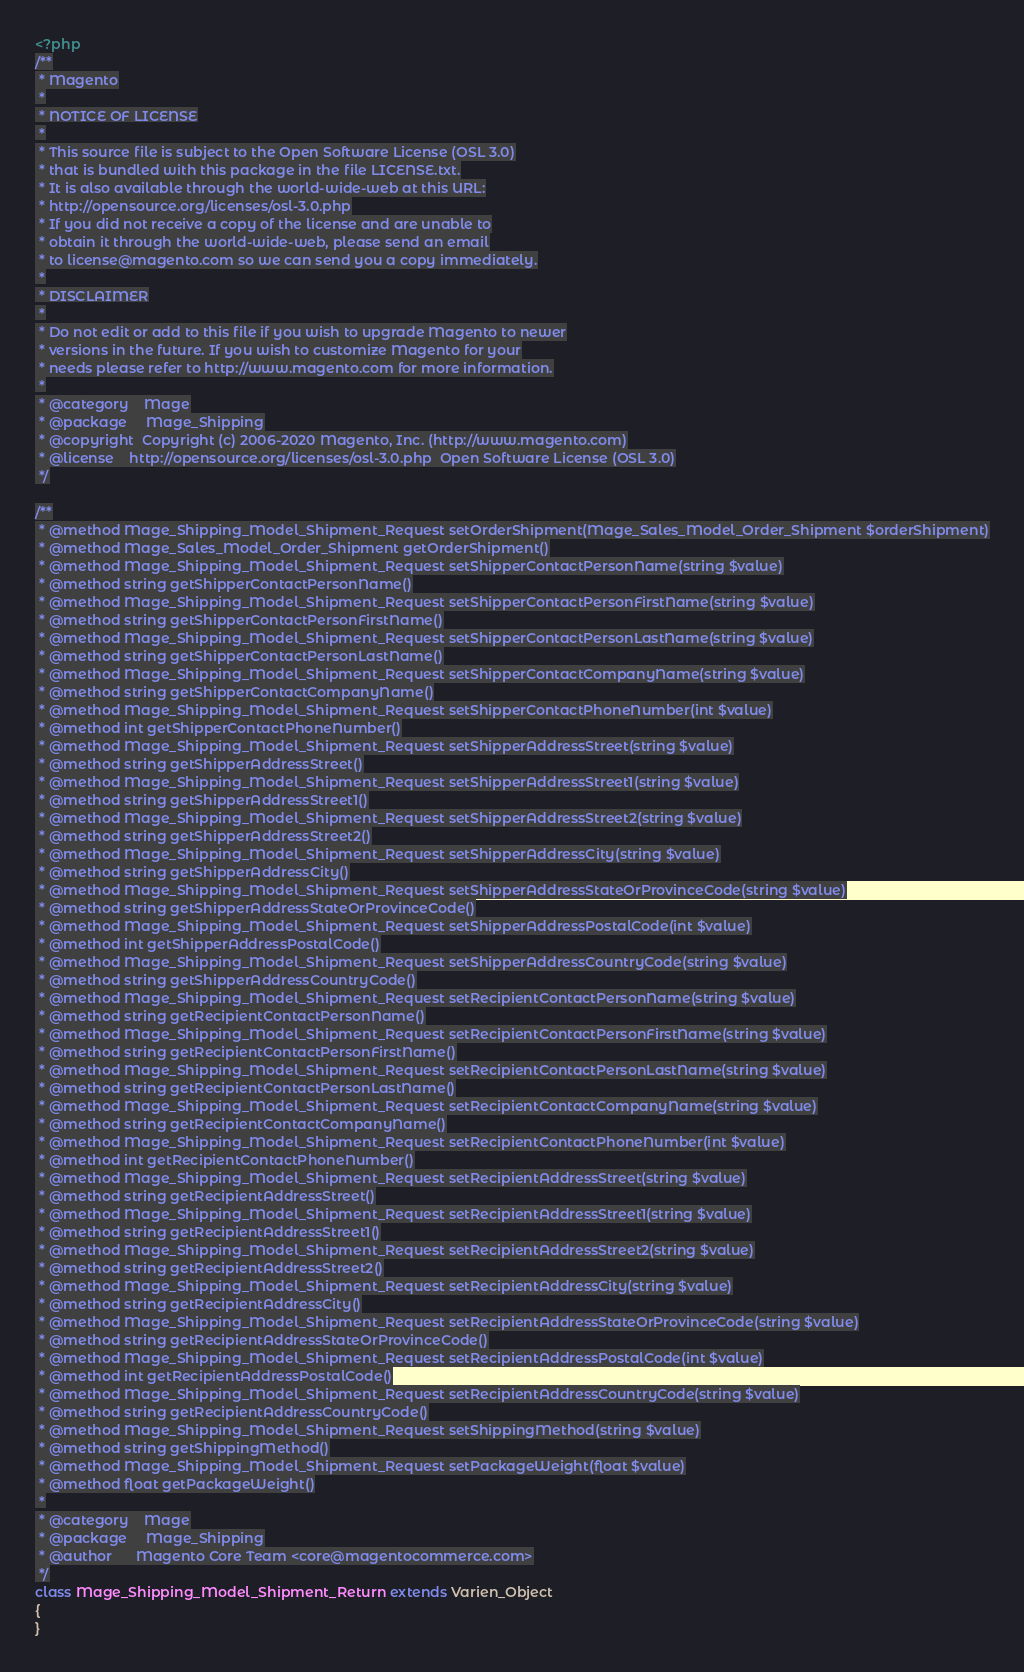Convert code to text. <code><loc_0><loc_0><loc_500><loc_500><_PHP_><?php
/**
 * Magento
 *
 * NOTICE OF LICENSE
 *
 * This source file is subject to the Open Software License (OSL 3.0)
 * that is bundled with this package in the file LICENSE.txt.
 * It is also available through the world-wide-web at this URL:
 * http://opensource.org/licenses/osl-3.0.php
 * If you did not receive a copy of the license and are unable to
 * obtain it through the world-wide-web, please send an email
 * to license@magento.com so we can send you a copy immediately.
 *
 * DISCLAIMER
 *
 * Do not edit or add to this file if you wish to upgrade Magento to newer
 * versions in the future. If you wish to customize Magento for your
 * needs please refer to http://www.magento.com for more information.
 *
 * @category    Mage
 * @package     Mage_Shipping
 * @copyright  Copyright (c) 2006-2020 Magento, Inc. (http://www.magento.com)
 * @license    http://opensource.org/licenses/osl-3.0.php  Open Software License (OSL 3.0)
 */

/**
 * @method Mage_Shipping_Model_Shipment_Request setOrderShipment(Mage_Sales_Model_Order_Shipment $orderShipment)
 * @method Mage_Sales_Model_Order_Shipment getOrderShipment()
 * @method Mage_Shipping_Model_Shipment_Request setShipperContactPersonName(string $value)
 * @method string getShipperContactPersonName()
 * @method Mage_Shipping_Model_Shipment_Request setShipperContactPersonFirstName(string $value)
 * @method string getShipperContactPersonFirstName()
 * @method Mage_Shipping_Model_Shipment_Request setShipperContactPersonLastName(string $value)
 * @method string getShipperContactPersonLastName()
 * @method Mage_Shipping_Model_Shipment_Request setShipperContactCompanyName(string $value)
 * @method string getShipperContactCompanyName()
 * @method Mage_Shipping_Model_Shipment_Request setShipperContactPhoneNumber(int $value)
 * @method int getShipperContactPhoneNumber()
 * @method Mage_Shipping_Model_Shipment_Request setShipperAddressStreet(string $value)
 * @method string getShipperAddressStreet()
 * @method Mage_Shipping_Model_Shipment_Request setShipperAddressStreet1(string $value)
 * @method string getShipperAddressStreet1()
 * @method Mage_Shipping_Model_Shipment_Request setShipperAddressStreet2(string $value)
 * @method string getShipperAddressStreet2()
 * @method Mage_Shipping_Model_Shipment_Request setShipperAddressCity(string $value)
 * @method string getShipperAddressCity()
 * @method Mage_Shipping_Model_Shipment_Request setShipperAddressStateOrProvinceCode(string $value)
 * @method string getShipperAddressStateOrProvinceCode()
 * @method Mage_Shipping_Model_Shipment_Request setShipperAddressPostalCode(int $value)
 * @method int getShipperAddressPostalCode()
 * @method Mage_Shipping_Model_Shipment_Request setShipperAddressCountryCode(string $value)
 * @method string getShipperAddressCountryCode()
 * @method Mage_Shipping_Model_Shipment_Request setRecipientContactPersonName(string $value)
 * @method string getRecipientContactPersonName()
 * @method Mage_Shipping_Model_Shipment_Request setRecipientContactPersonFirstName(string $value)
 * @method string getRecipientContactPersonFirstName()
 * @method Mage_Shipping_Model_Shipment_Request setRecipientContactPersonLastName(string $value)
 * @method string getRecipientContactPersonLastName()
 * @method Mage_Shipping_Model_Shipment_Request setRecipientContactCompanyName(string $value)
 * @method string getRecipientContactCompanyName()
 * @method Mage_Shipping_Model_Shipment_Request setRecipientContactPhoneNumber(int $value)
 * @method int getRecipientContactPhoneNumber()
 * @method Mage_Shipping_Model_Shipment_Request setRecipientAddressStreet(string $value)
 * @method string getRecipientAddressStreet()
 * @method Mage_Shipping_Model_Shipment_Request setRecipientAddressStreet1(string $value)
 * @method string getRecipientAddressStreet1()
 * @method Mage_Shipping_Model_Shipment_Request setRecipientAddressStreet2(string $value)
 * @method string getRecipientAddressStreet2()
 * @method Mage_Shipping_Model_Shipment_Request setRecipientAddressCity(string $value)
 * @method string getRecipientAddressCity()
 * @method Mage_Shipping_Model_Shipment_Request setRecipientAddressStateOrProvinceCode(string $value)
 * @method string getRecipientAddressStateOrProvinceCode()
 * @method Mage_Shipping_Model_Shipment_Request setRecipientAddressPostalCode(int $value)
 * @method int getRecipientAddressPostalCode()
 * @method Mage_Shipping_Model_Shipment_Request setRecipientAddressCountryCode(string $value)
 * @method string getRecipientAddressCountryCode()
 * @method Mage_Shipping_Model_Shipment_Request setShippingMethod(string $value)
 * @method string getShippingMethod()
 * @method Mage_Shipping_Model_Shipment_Request setPackageWeight(float $value)
 * @method float getPackageWeight()
 *
 * @category    Mage
 * @package     Mage_Shipping
 * @author      Magento Core Team <core@magentocommerce.com>
 */
class Mage_Shipping_Model_Shipment_Return extends Varien_Object
{
}
</code> 